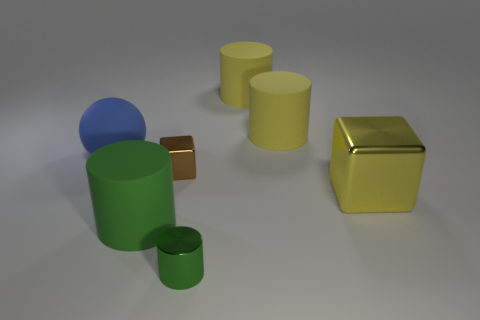Subtract all red cylinders. Subtract all purple balls. How many cylinders are left? 4 Add 2 matte things. How many objects exist? 9 Subtract all cylinders. How many objects are left? 3 Add 3 small brown objects. How many small brown objects are left? 4 Add 5 matte balls. How many matte balls exist? 6 Subtract 0 cyan cylinders. How many objects are left? 7 Subtract all large red cylinders. Subtract all green objects. How many objects are left? 5 